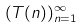<formula> <loc_0><loc_0><loc_500><loc_500>( T ( n ) ) _ { n = 1 } ^ { \infty }</formula> 